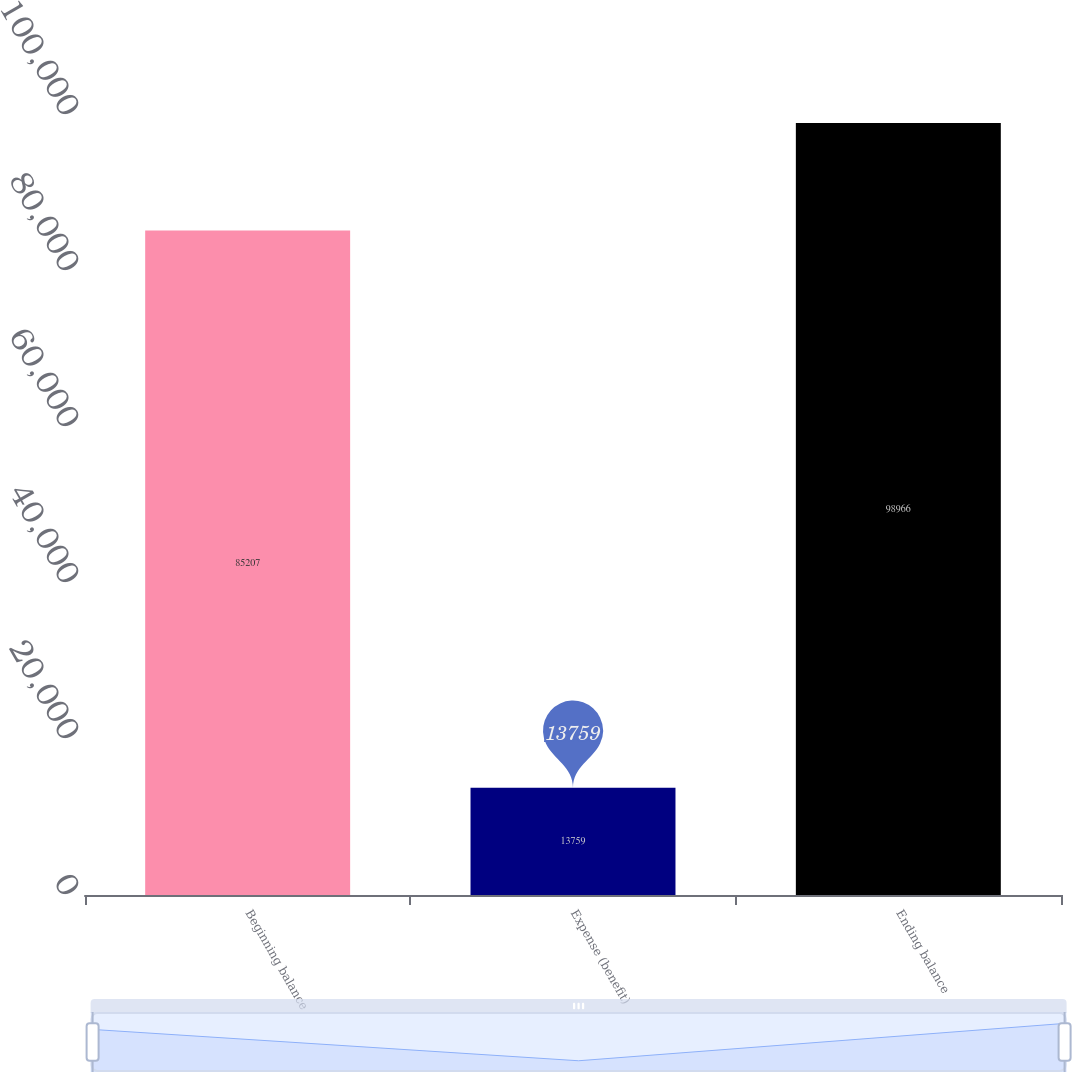Convert chart. <chart><loc_0><loc_0><loc_500><loc_500><bar_chart><fcel>Beginning balance<fcel>Expense (benefit)<fcel>Ending balance<nl><fcel>85207<fcel>13759<fcel>98966<nl></chart> 